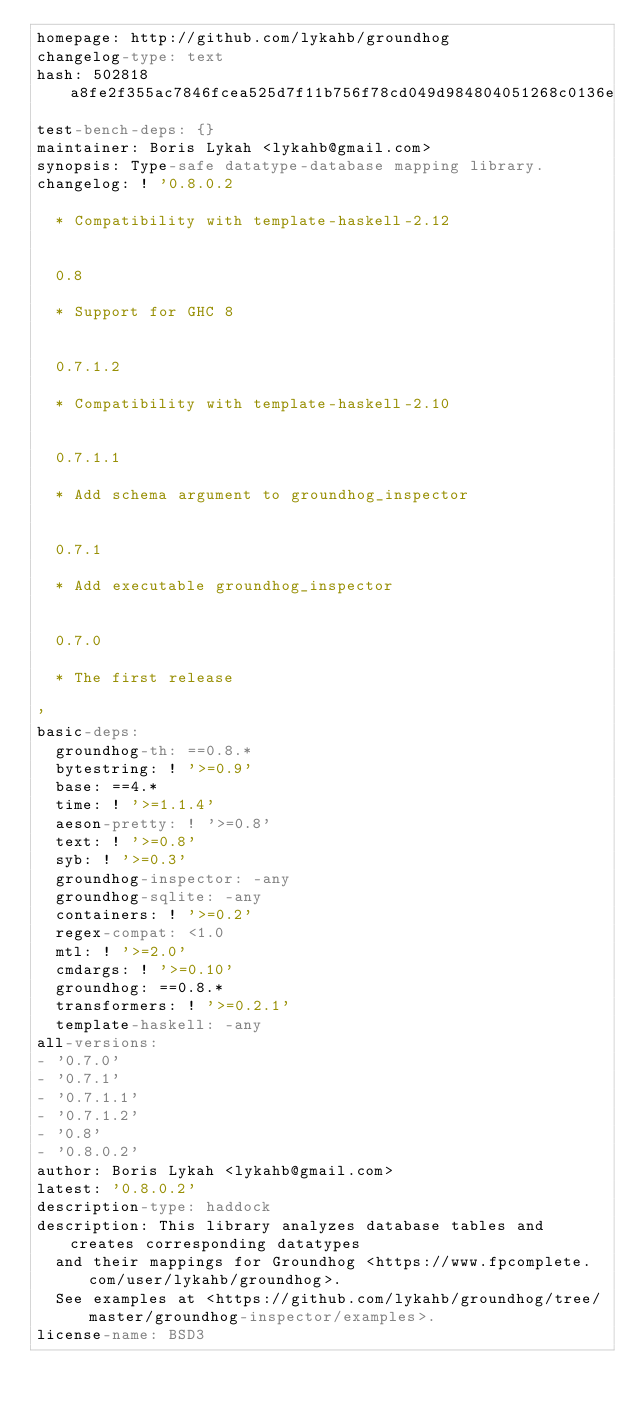Convert code to text. <code><loc_0><loc_0><loc_500><loc_500><_YAML_>homepage: http://github.com/lykahb/groundhog
changelog-type: text
hash: 502818a8fe2f355ac7846fcea525d7f11b756f78cd049d984804051268c0136e
test-bench-deps: {}
maintainer: Boris Lykah <lykahb@gmail.com>
synopsis: Type-safe datatype-database mapping library.
changelog: ! '0.8.0.2

  * Compatibility with template-haskell-2.12


  0.8

  * Support for GHC 8


  0.7.1.2

  * Compatibility with template-haskell-2.10


  0.7.1.1

  * Add schema argument to groundhog_inspector


  0.7.1

  * Add executable groundhog_inspector


  0.7.0

  * The first release

'
basic-deps:
  groundhog-th: ==0.8.*
  bytestring: ! '>=0.9'
  base: ==4.*
  time: ! '>=1.1.4'
  aeson-pretty: ! '>=0.8'
  text: ! '>=0.8'
  syb: ! '>=0.3'
  groundhog-inspector: -any
  groundhog-sqlite: -any
  containers: ! '>=0.2'
  regex-compat: <1.0
  mtl: ! '>=2.0'
  cmdargs: ! '>=0.10'
  groundhog: ==0.8.*
  transformers: ! '>=0.2.1'
  template-haskell: -any
all-versions:
- '0.7.0'
- '0.7.1'
- '0.7.1.1'
- '0.7.1.2'
- '0.8'
- '0.8.0.2'
author: Boris Lykah <lykahb@gmail.com>
latest: '0.8.0.2'
description-type: haddock
description: This library analyzes database tables and creates corresponding datatypes
  and their mappings for Groundhog <https://www.fpcomplete.com/user/lykahb/groundhog>.
  See examples at <https://github.com/lykahb/groundhog/tree/master/groundhog-inspector/examples>.
license-name: BSD3
</code> 